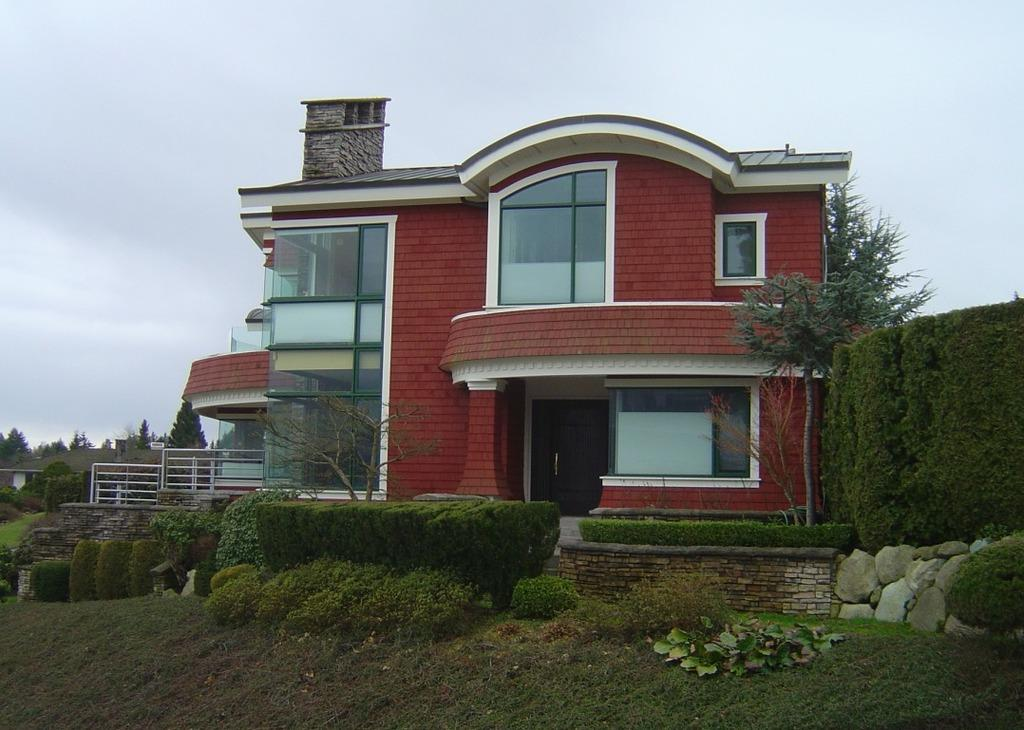What type of vegetation can be seen in the image? There is grass, plants, and trees in the image. What color is the building in the image? The building in the image is red. What type of ground surface is visible in the image? There are stones in the image. What is the condition of the sky in the background of the image? The sky is cloudy in the background of the image. How many cherries are hanging from the trees in the image? There are no cherries visible in the image; it features trees without any fruit. What order is the grandfather giving to the plants in the image? There is no grandfather present in the image, and therefore no order can be given to the plants. 